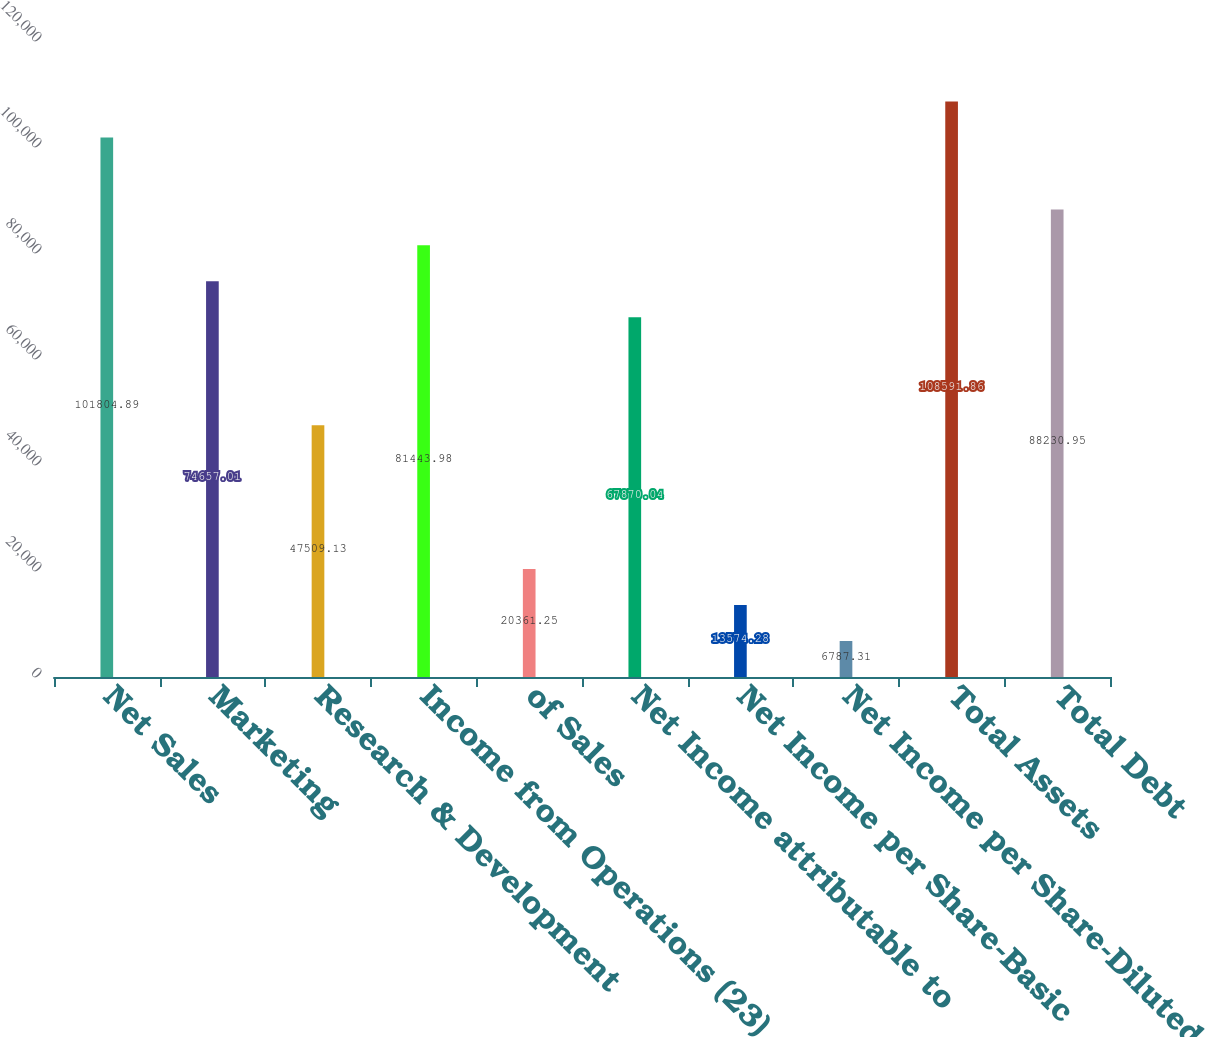Convert chart. <chart><loc_0><loc_0><loc_500><loc_500><bar_chart><fcel>Net Sales<fcel>Marketing<fcel>Research & Development<fcel>Income from Operations (23)<fcel>of Sales<fcel>Net Income attributable to<fcel>Net Income per Share-Basic<fcel>Net Income per Share-Diluted<fcel>Total Assets<fcel>Total Debt<nl><fcel>101805<fcel>74657<fcel>47509.1<fcel>81444<fcel>20361.2<fcel>67870<fcel>13574.3<fcel>6787.31<fcel>108592<fcel>88230.9<nl></chart> 